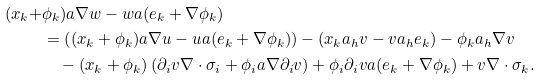Convert formula to latex. <formula><loc_0><loc_0><loc_500><loc_500>( x _ { k } + & \phi _ { k } ) a \nabla w - w a ( e _ { k } + \nabla \phi _ { k } ) \\ & = \left ( ( x _ { k } + \phi _ { k } ) a \nabla u - u a ( e _ { k } + \nabla \phi _ { k } ) \right ) - \left ( x _ { k } a _ { h } v - v a _ { h } e _ { k } \right ) - \phi _ { k } a _ { h } \nabla v \\ & \quad - ( x _ { k } + \phi _ { k } ) \left ( \partial _ { i } v \nabla \cdot \sigma _ { i } + \phi _ { i } a \nabla \partial _ { i } v \right ) + \phi _ { i } \partial _ { i } v a ( e _ { k } + \nabla \phi _ { k } ) + v \nabla \cdot \sigma _ { k } .</formula> 